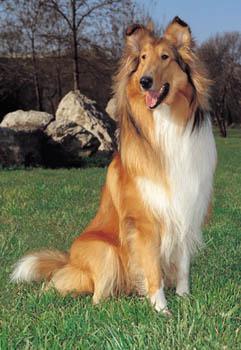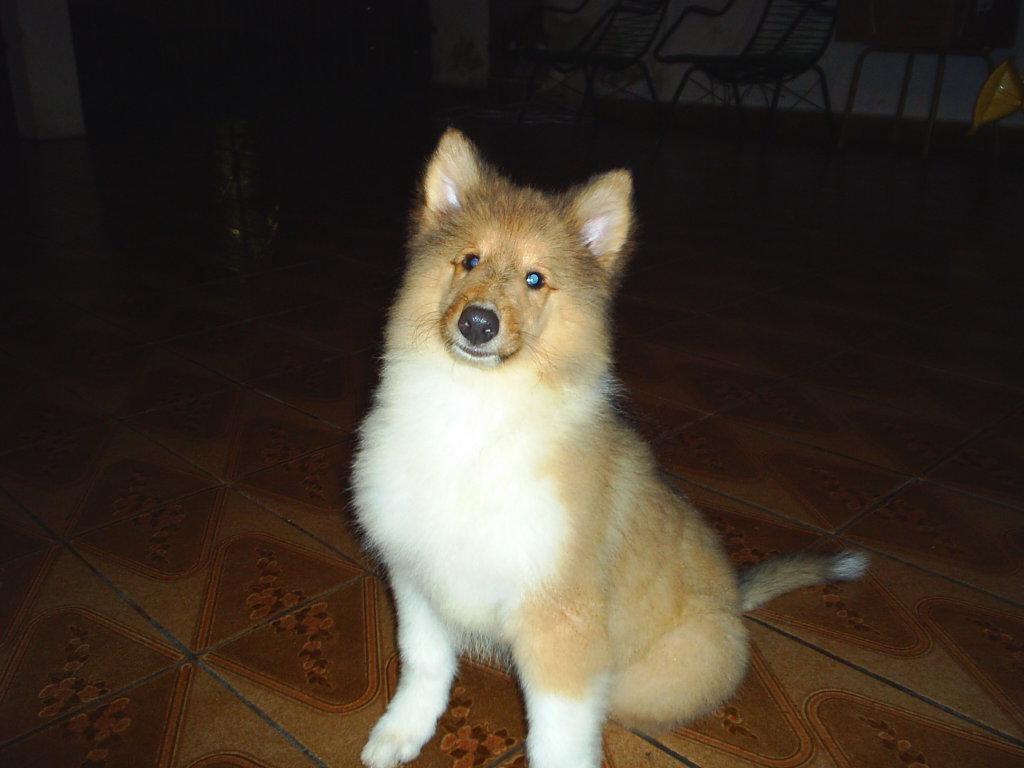The first image is the image on the left, the second image is the image on the right. For the images shown, is this caption "the collie on the left image is sitting with its front legs straight up." true? Answer yes or no. Yes. 